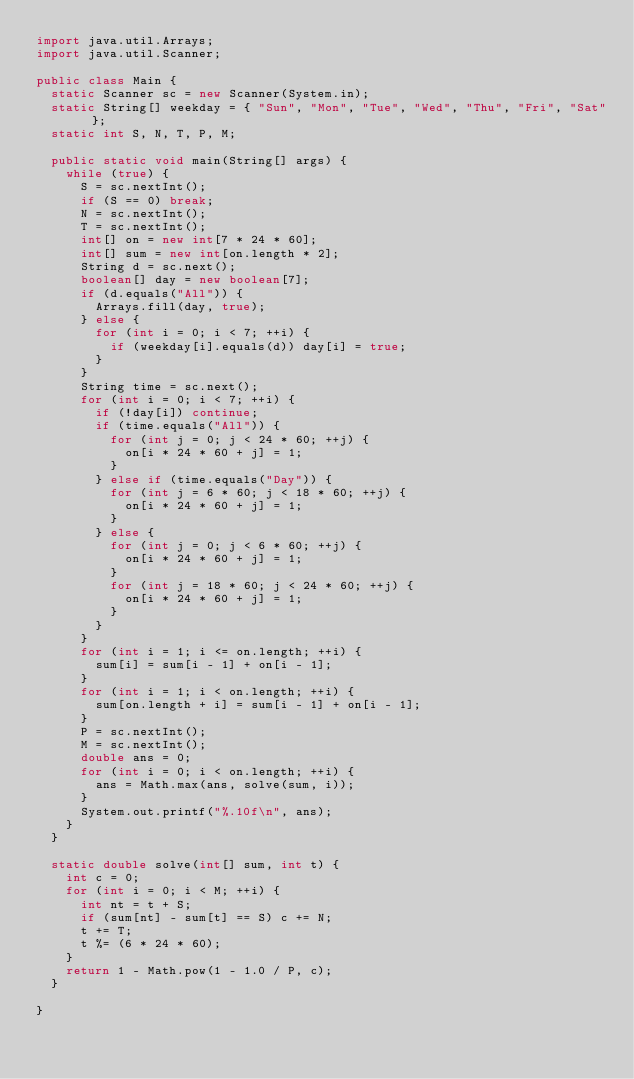Convert code to text. <code><loc_0><loc_0><loc_500><loc_500><_Java_>import java.util.Arrays;
import java.util.Scanner;

public class Main {
	static Scanner sc = new Scanner(System.in);
	static String[] weekday = { "Sun", "Mon", "Tue", "Wed", "Thu", "Fri", "Sat" };
	static int S, N, T, P, M;

	public static void main(String[] args) {
		while (true) {
			S = sc.nextInt();
			if (S == 0) break;
			N = sc.nextInt();
			T = sc.nextInt();
			int[] on = new int[7 * 24 * 60];
			int[] sum = new int[on.length * 2];
			String d = sc.next();
			boolean[] day = new boolean[7];
			if (d.equals("All")) {
				Arrays.fill(day, true);
			} else {
				for (int i = 0; i < 7; ++i) {
					if (weekday[i].equals(d)) day[i] = true;
				}
			}
			String time = sc.next();
			for (int i = 0; i < 7; ++i) {
				if (!day[i]) continue;
				if (time.equals("All")) {
					for (int j = 0; j < 24 * 60; ++j) {
						on[i * 24 * 60 + j] = 1;
					}
				} else if (time.equals("Day")) {
					for (int j = 6 * 60; j < 18 * 60; ++j) {
						on[i * 24 * 60 + j] = 1;
					}
				} else {
					for (int j = 0; j < 6 * 60; ++j) {
						on[i * 24 * 60 + j] = 1;
					}
					for (int j = 18 * 60; j < 24 * 60; ++j) {
						on[i * 24 * 60 + j] = 1;
					}
				}
			}
			for (int i = 1; i <= on.length; ++i) {
				sum[i] = sum[i - 1] + on[i - 1];
			}
			for (int i = 1; i < on.length; ++i) {
				sum[on.length + i] = sum[i - 1] + on[i - 1];
			}
			P = sc.nextInt();
			M = sc.nextInt();
			double ans = 0;
			for (int i = 0; i < on.length; ++i) {
				ans = Math.max(ans, solve(sum, i));
			}
			System.out.printf("%.10f\n", ans);
		}
	}

	static double solve(int[] sum, int t) {
		int c = 0;
		for (int i = 0; i < M; ++i) {
			int nt = t + S;
			if (sum[nt] - sum[t] == S) c += N;
			t += T;
			t %= (6 * 24 * 60);
		}
		return 1 - Math.pow(1 - 1.0 / P, c);
	}

}</code> 